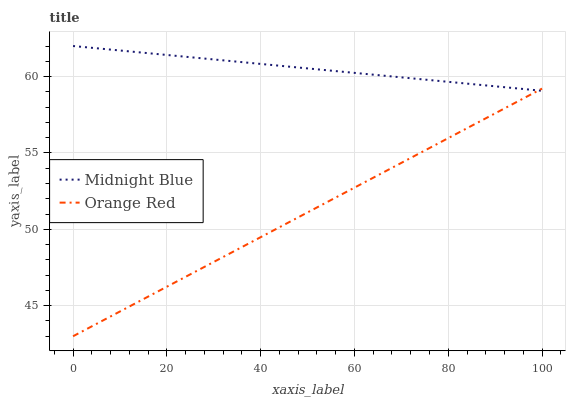Does Orange Red have the minimum area under the curve?
Answer yes or no. Yes. Does Midnight Blue have the maximum area under the curve?
Answer yes or no. Yes. Does Orange Red have the maximum area under the curve?
Answer yes or no. No. Is Orange Red the smoothest?
Answer yes or no. Yes. Is Midnight Blue the roughest?
Answer yes or no. Yes. Is Orange Red the roughest?
Answer yes or no. No. Does Orange Red have the lowest value?
Answer yes or no. Yes. Does Midnight Blue have the highest value?
Answer yes or no. Yes. Does Orange Red have the highest value?
Answer yes or no. No. Does Orange Red intersect Midnight Blue?
Answer yes or no. Yes. Is Orange Red less than Midnight Blue?
Answer yes or no. No. Is Orange Red greater than Midnight Blue?
Answer yes or no. No. 